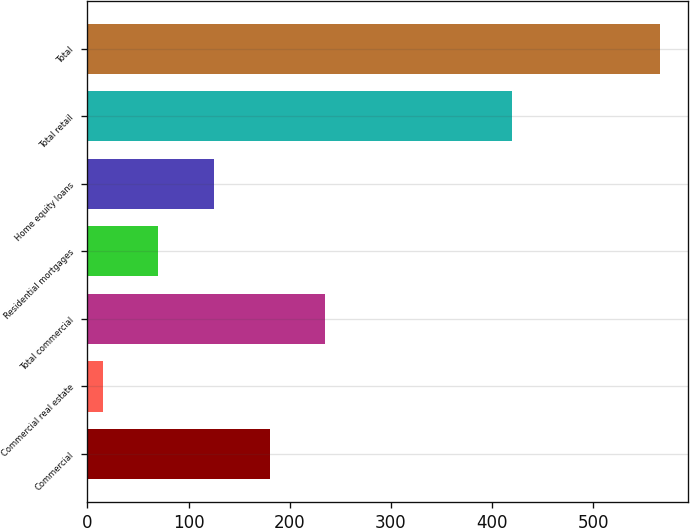Convert chart to OTSL. <chart><loc_0><loc_0><loc_500><loc_500><bar_chart><fcel>Commercial<fcel>Commercial real estate<fcel>Total commercial<fcel>Residential mortgages<fcel>Home equity loans<fcel>Total retail<fcel>Total<nl><fcel>180.3<fcel>15<fcel>235.4<fcel>70.1<fcel>125.2<fcel>420<fcel>566<nl></chart> 